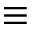Convert formula to latex. <formula><loc_0><loc_0><loc_500><loc_500>\equiv</formula> 